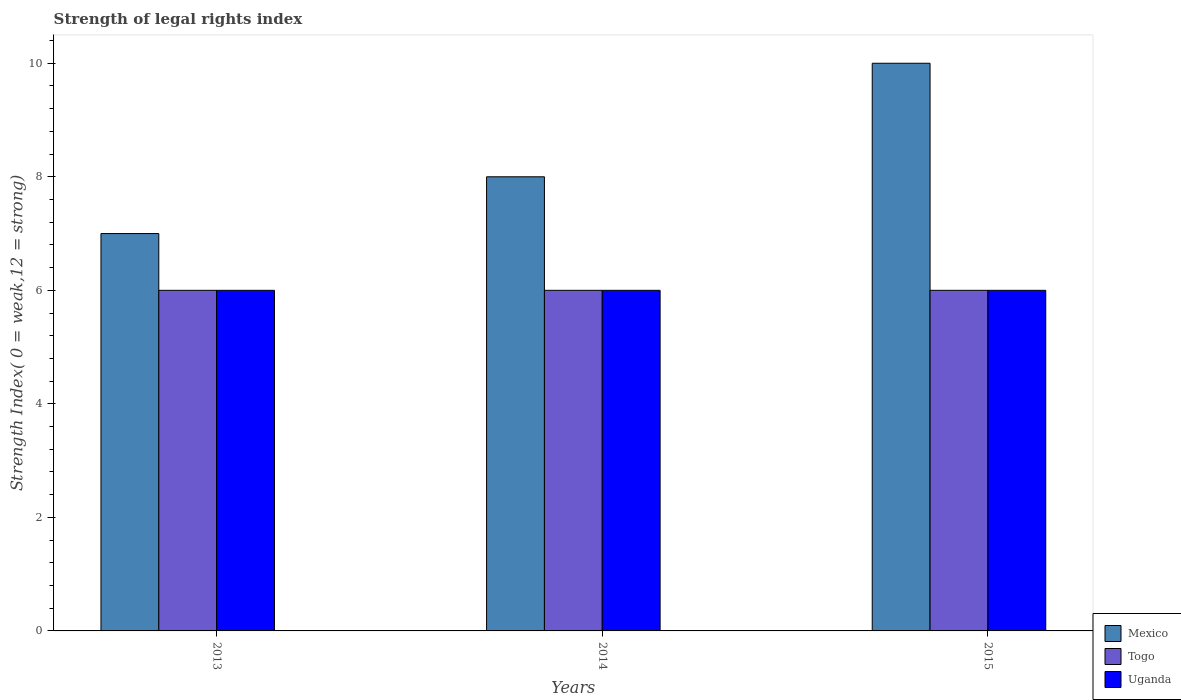Are the number of bars on each tick of the X-axis equal?
Give a very brief answer. Yes. How many bars are there on the 2nd tick from the right?
Your answer should be compact. 3. What is the label of the 3rd group of bars from the left?
Give a very brief answer. 2015. Across all years, what is the maximum strength index in Mexico?
Your answer should be very brief. 10. Across all years, what is the minimum strength index in Mexico?
Offer a very short reply. 7. In which year was the strength index in Togo maximum?
Offer a very short reply. 2013. In which year was the strength index in Mexico minimum?
Offer a terse response. 2013. What is the total strength index in Uganda in the graph?
Offer a terse response. 18. What is the difference between the strength index in Uganda in 2013 and that in 2015?
Offer a very short reply. 0. What is the difference between the strength index in Uganda in 2015 and the strength index in Mexico in 2014?
Your answer should be compact. -2. In the year 2014, what is the difference between the strength index in Mexico and strength index in Uganda?
Your response must be concise. 2. What is the difference between the highest and the lowest strength index in Mexico?
Give a very brief answer. 3. In how many years, is the strength index in Mexico greater than the average strength index in Mexico taken over all years?
Give a very brief answer. 1. Is the sum of the strength index in Uganda in 2013 and 2014 greater than the maximum strength index in Togo across all years?
Your answer should be very brief. Yes. What does the 1st bar from the left in 2015 represents?
Keep it short and to the point. Mexico. What does the 1st bar from the right in 2015 represents?
Give a very brief answer. Uganda. How many bars are there?
Offer a terse response. 9. How many legend labels are there?
Offer a very short reply. 3. What is the title of the graph?
Offer a very short reply. Strength of legal rights index. Does "Portugal" appear as one of the legend labels in the graph?
Ensure brevity in your answer.  No. What is the label or title of the Y-axis?
Your answer should be compact. Strength Index( 0 = weak,12 = strong). What is the Strength Index( 0 = weak,12 = strong) of Uganda in 2013?
Your answer should be very brief. 6. What is the Strength Index( 0 = weak,12 = strong) of Mexico in 2014?
Offer a terse response. 8. What is the Strength Index( 0 = weak,12 = strong) in Togo in 2014?
Your answer should be very brief. 6. What is the Strength Index( 0 = weak,12 = strong) in Uganda in 2014?
Make the answer very short. 6. What is the Strength Index( 0 = weak,12 = strong) of Uganda in 2015?
Your answer should be very brief. 6. Across all years, what is the maximum Strength Index( 0 = weak,12 = strong) of Mexico?
Your answer should be compact. 10. Across all years, what is the maximum Strength Index( 0 = weak,12 = strong) of Togo?
Offer a very short reply. 6. Across all years, what is the minimum Strength Index( 0 = weak,12 = strong) in Mexico?
Your answer should be compact. 7. Across all years, what is the minimum Strength Index( 0 = weak,12 = strong) in Togo?
Your answer should be compact. 6. Across all years, what is the minimum Strength Index( 0 = weak,12 = strong) of Uganda?
Your response must be concise. 6. What is the total Strength Index( 0 = weak,12 = strong) of Mexico in the graph?
Your answer should be compact. 25. What is the total Strength Index( 0 = weak,12 = strong) in Togo in the graph?
Make the answer very short. 18. What is the total Strength Index( 0 = weak,12 = strong) in Uganda in the graph?
Provide a succinct answer. 18. What is the difference between the Strength Index( 0 = weak,12 = strong) in Mexico in 2013 and that in 2014?
Give a very brief answer. -1. What is the difference between the Strength Index( 0 = weak,12 = strong) in Togo in 2013 and that in 2014?
Provide a short and direct response. 0. What is the difference between the Strength Index( 0 = weak,12 = strong) of Uganda in 2013 and that in 2014?
Provide a short and direct response. 0. What is the difference between the Strength Index( 0 = weak,12 = strong) in Togo in 2013 and that in 2015?
Offer a terse response. 0. What is the difference between the Strength Index( 0 = weak,12 = strong) in Togo in 2014 and that in 2015?
Give a very brief answer. 0. What is the difference between the Strength Index( 0 = weak,12 = strong) in Uganda in 2014 and that in 2015?
Offer a very short reply. 0. What is the difference between the Strength Index( 0 = weak,12 = strong) in Mexico in 2013 and the Strength Index( 0 = weak,12 = strong) in Uganda in 2014?
Make the answer very short. 1. What is the difference between the Strength Index( 0 = weak,12 = strong) in Mexico in 2013 and the Strength Index( 0 = weak,12 = strong) in Uganda in 2015?
Keep it short and to the point. 1. What is the difference between the Strength Index( 0 = weak,12 = strong) in Mexico in 2014 and the Strength Index( 0 = weak,12 = strong) in Togo in 2015?
Provide a short and direct response. 2. What is the difference between the Strength Index( 0 = weak,12 = strong) of Mexico in 2014 and the Strength Index( 0 = weak,12 = strong) of Uganda in 2015?
Give a very brief answer. 2. What is the difference between the Strength Index( 0 = weak,12 = strong) of Togo in 2014 and the Strength Index( 0 = weak,12 = strong) of Uganda in 2015?
Make the answer very short. 0. What is the average Strength Index( 0 = weak,12 = strong) of Mexico per year?
Give a very brief answer. 8.33. What is the average Strength Index( 0 = weak,12 = strong) of Togo per year?
Your response must be concise. 6. What is the average Strength Index( 0 = weak,12 = strong) in Uganda per year?
Give a very brief answer. 6. In the year 2013, what is the difference between the Strength Index( 0 = weak,12 = strong) in Mexico and Strength Index( 0 = weak,12 = strong) in Uganda?
Give a very brief answer. 1. In the year 2014, what is the difference between the Strength Index( 0 = weak,12 = strong) in Mexico and Strength Index( 0 = weak,12 = strong) in Uganda?
Ensure brevity in your answer.  2. In the year 2015, what is the difference between the Strength Index( 0 = weak,12 = strong) in Togo and Strength Index( 0 = weak,12 = strong) in Uganda?
Your answer should be very brief. 0. What is the ratio of the Strength Index( 0 = weak,12 = strong) in Mexico in 2013 to that in 2014?
Offer a very short reply. 0.88. What is the ratio of the Strength Index( 0 = weak,12 = strong) in Uganda in 2013 to that in 2015?
Provide a succinct answer. 1. What is the difference between the highest and the second highest Strength Index( 0 = weak,12 = strong) in Mexico?
Offer a very short reply. 2. What is the difference between the highest and the lowest Strength Index( 0 = weak,12 = strong) in Mexico?
Keep it short and to the point. 3. 